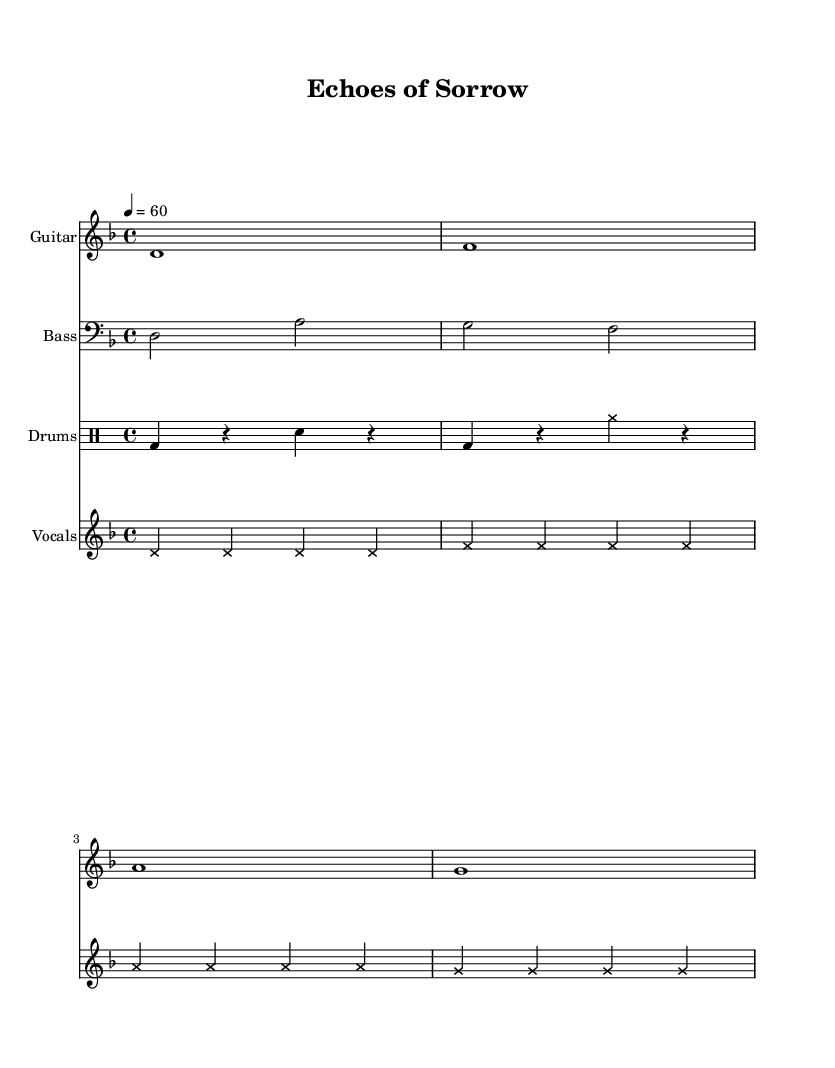What is the key signature of this music? The key signature is D minor, which has one flat (B flat). It is indicated at the beginning of the score with the 'D' note after the word "key".
Answer: D minor What is the time signature of this music? The time signature is 4/4, which means there are four beats in each measure. This is shown at the beginning of the score with the numerals 4 over 4.
Answer: 4/4 What is the tempo marking of this piece? The tempo marking indicates a speed of 60 beats per minute, as noted by "4 = 60" at the beginning of the score, meaning the quarter note gets one beat and there are 60 beats in one minute.
Answer: 60 How many measures does the guitar riff consist of? The guitar riff consists of four measures, which can be counted by identifying the bars in the music notation for the guitar part. Each vertical line indicates the end of a measure, and there are four lines in the provided riff.
Answer: 4 What is the distinctive vocal style used in this piece? The vocal style used in this piece is marked with cross note heads, which are indicative of a growling or screaming vocal technique typical in metal music. This style adds to the heavy emotional weight of the piece.
Answer: Cross What instruments are included in this score? The score includes four different instruments: Guitar, Bass, Drums, and Vocals. Each one is notated on separate staves, indicated by the instrument names at the beginning of each staff.
Answer: Guitar, Bass, Drums, Vocals How does the drum pattern contribute to the overall feel of the piece? The drum pattern consists of a kick drum and snare rhythm with rests, contributing to a heavy, driving feel typical of doom metal. The alternating rests and strikes create a sense of tension and anticipation that complements the somber theme of the piece.
Answer: Heavy, driving 